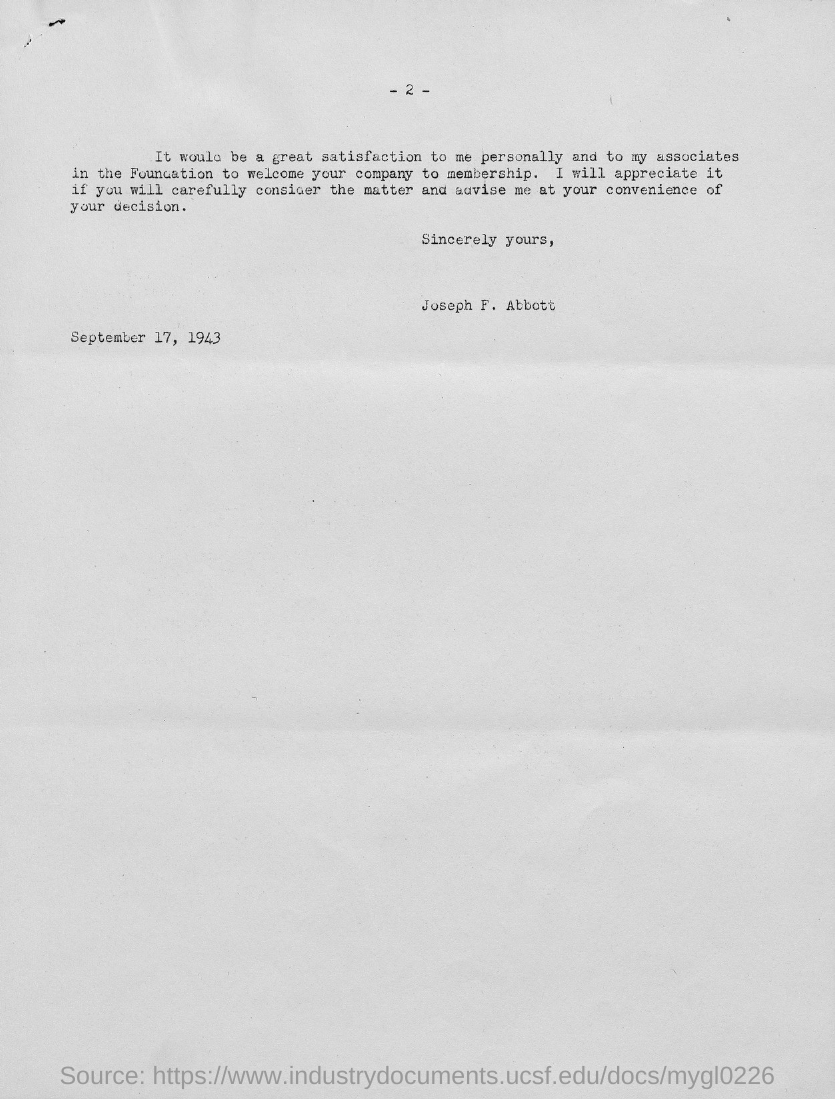Who has written this letter?
Your answer should be compact. Joseph F. Abbott. What is the date mentioned in the letter?
Keep it short and to the point. September 17, 1943. What is the page number written on the top of the page?
Offer a terse response. 2. 